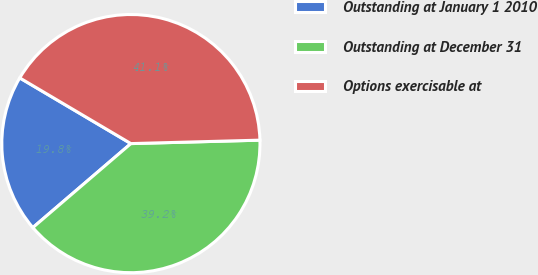<chart> <loc_0><loc_0><loc_500><loc_500><pie_chart><fcel>Outstanding at January 1 2010<fcel>Outstanding at December 31<fcel>Options exercisable at<nl><fcel>19.77%<fcel>39.15%<fcel>41.08%<nl></chart> 